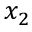<formula> <loc_0><loc_0><loc_500><loc_500>x _ { 2 }</formula> 